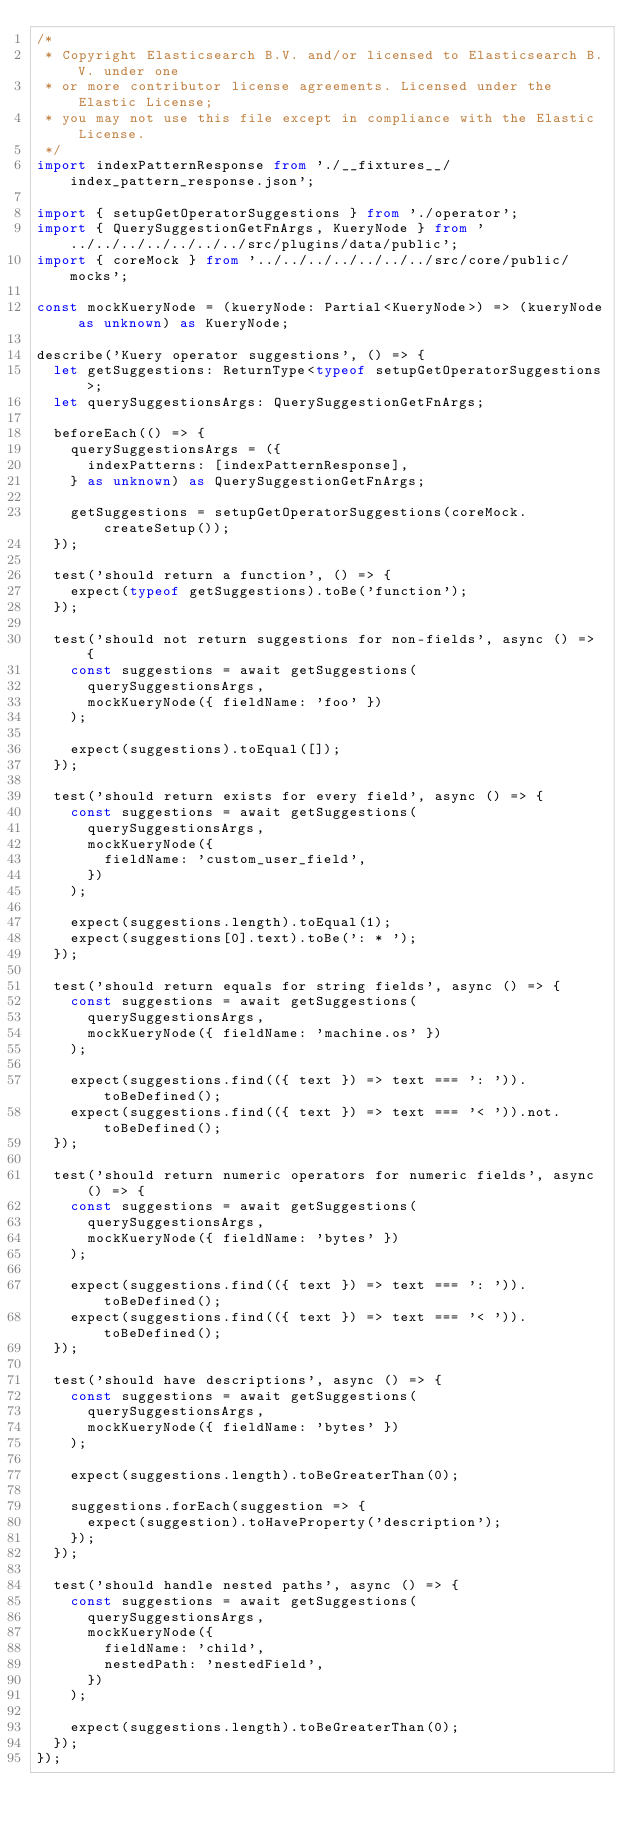<code> <loc_0><loc_0><loc_500><loc_500><_TypeScript_>/*
 * Copyright Elasticsearch B.V. and/or licensed to Elasticsearch B.V. under one
 * or more contributor license agreements. Licensed under the Elastic License;
 * you may not use this file except in compliance with the Elastic License.
 */
import indexPatternResponse from './__fixtures__/index_pattern_response.json';

import { setupGetOperatorSuggestions } from './operator';
import { QuerySuggestionGetFnArgs, KueryNode } from '../../../../../../../src/plugins/data/public';
import { coreMock } from '../../../../../../../src/core/public/mocks';

const mockKueryNode = (kueryNode: Partial<KueryNode>) => (kueryNode as unknown) as KueryNode;

describe('Kuery operator suggestions', () => {
  let getSuggestions: ReturnType<typeof setupGetOperatorSuggestions>;
  let querySuggestionsArgs: QuerySuggestionGetFnArgs;

  beforeEach(() => {
    querySuggestionsArgs = ({
      indexPatterns: [indexPatternResponse],
    } as unknown) as QuerySuggestionGetFnArgs;

    getSuggestions = setupGetOperatorSuggestions(coreMock.createSetup());
  });

  test('should return a function', () => {
    expect(typeof getSuggestions).toBe('function');
  });

  test('should not return suggestions for non-fields', async () => {
    const suggestions = await getSuggestions(
      querySuggestionsArgs,
      mockKueryNode({ fieldName: 'foo' })
    );

    expect(suggestions).toEqual([]);
  });

  test('should return exists for every field', async () => {
    const suggestions = await getSuggestions(
      querySuggestionsArgs,
      mockKueryNode({
        fieldName: 'custom_user_field',
      })
    );

    expect(suggestions.length).toEqual(1);
    expect(suggestions[0].text).toBe(': * ');
  });

  test('should return equals for string fields', async () => {
    const suggestions = await getSuggestions(
      querySuggestionsArgs,
      mockKueryNode({ fieldName: 'machine.os' })
    );

    expect(suggestions.find(({ text }) => text === ': ')).toBeDefined();
    expect(suggestions.find(({ text }) => text === '< ')).not.toBeDefined();
  });

  test('should return numeric operators for numeric fields', async () => {
    const suggestions = await getSuggestions(
      querySuggestionsArgs,
      mockKueryNode({ fieldName: 'bytes' })
    );

    expect(suggestions.find(({ text }) => text === ': ')).toBeDefined();
    expect(suggestions.find(({ text }) => text === '< ')).toBeDefined();
  });

  test('should have descriptions', async () => {
    const suggestions = await getSuggestions(
      querySuggestionsArgs,
      mockKueryNode({ fieldName: 'bytes' })
    );

    expect(suggestions.length).toBeGreaterThan(0);

    suggestions.forEach(suggestion => {
      expect(suggestion).toHaveProperty('description');
    });
  });

  test('should handle nested paths', async () => {
    const suggestions = await getSuggestions(
      querySuggestionsArgs,
      mockKueryNode({
        fieldName: 'child',
        nestedPath: 'nestedField',
      })
    );

    expect(suggestions.length).toBeGreaterThan(0);
  });
});
</code> 